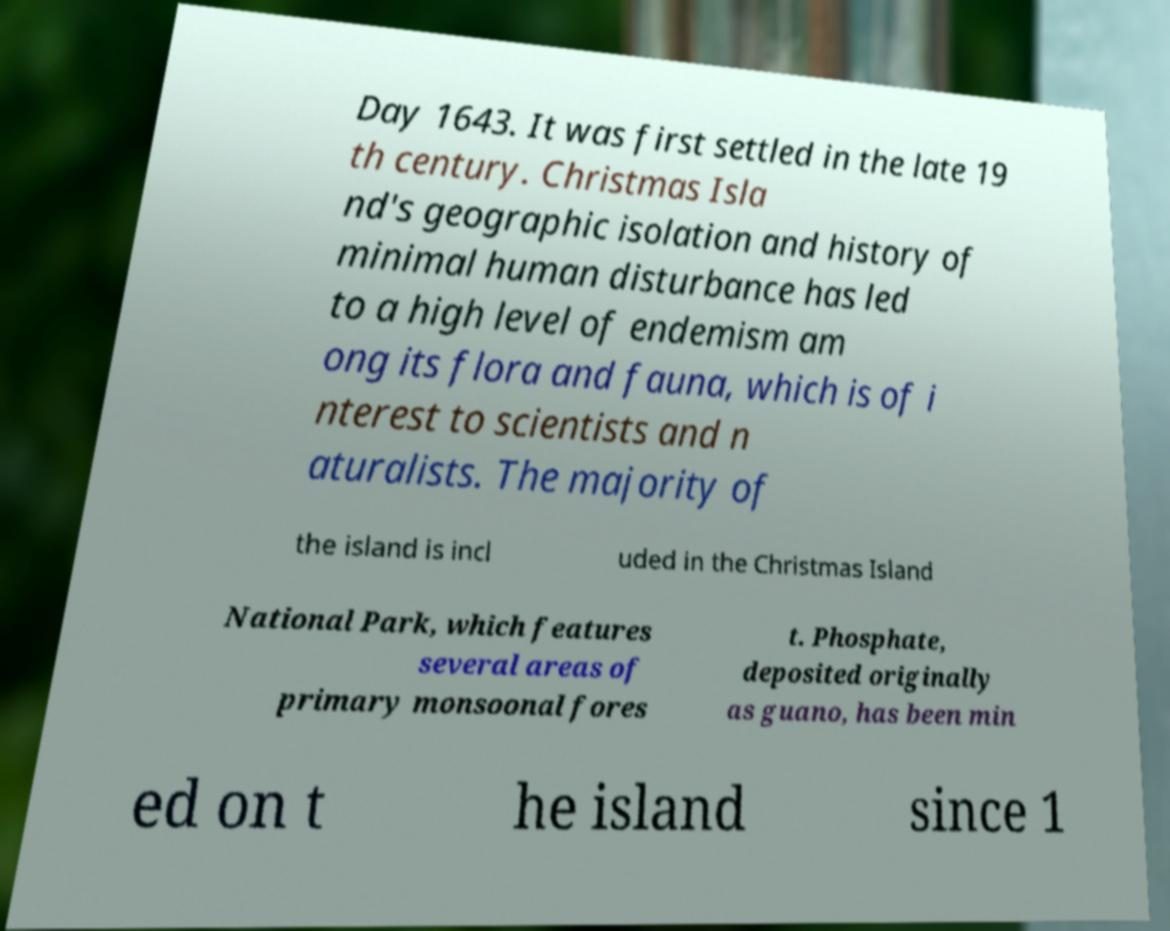I need the written content from this picture converted into text. Can you do that? Day 1643. It was first settled in the late 19 th century. Christmas Isla nd's geographic isolation and history of minimal human disturbance has led to a high level of endemism am ong its flora and fauna, which is of i nterest to scientists and n aturalists. The majority of the island is incl uded in the Christmas Island National Park, which features several areas of primary monsoonal fores t. Phosphate, deposited originally as guano, has been min ed on t he island since 1 